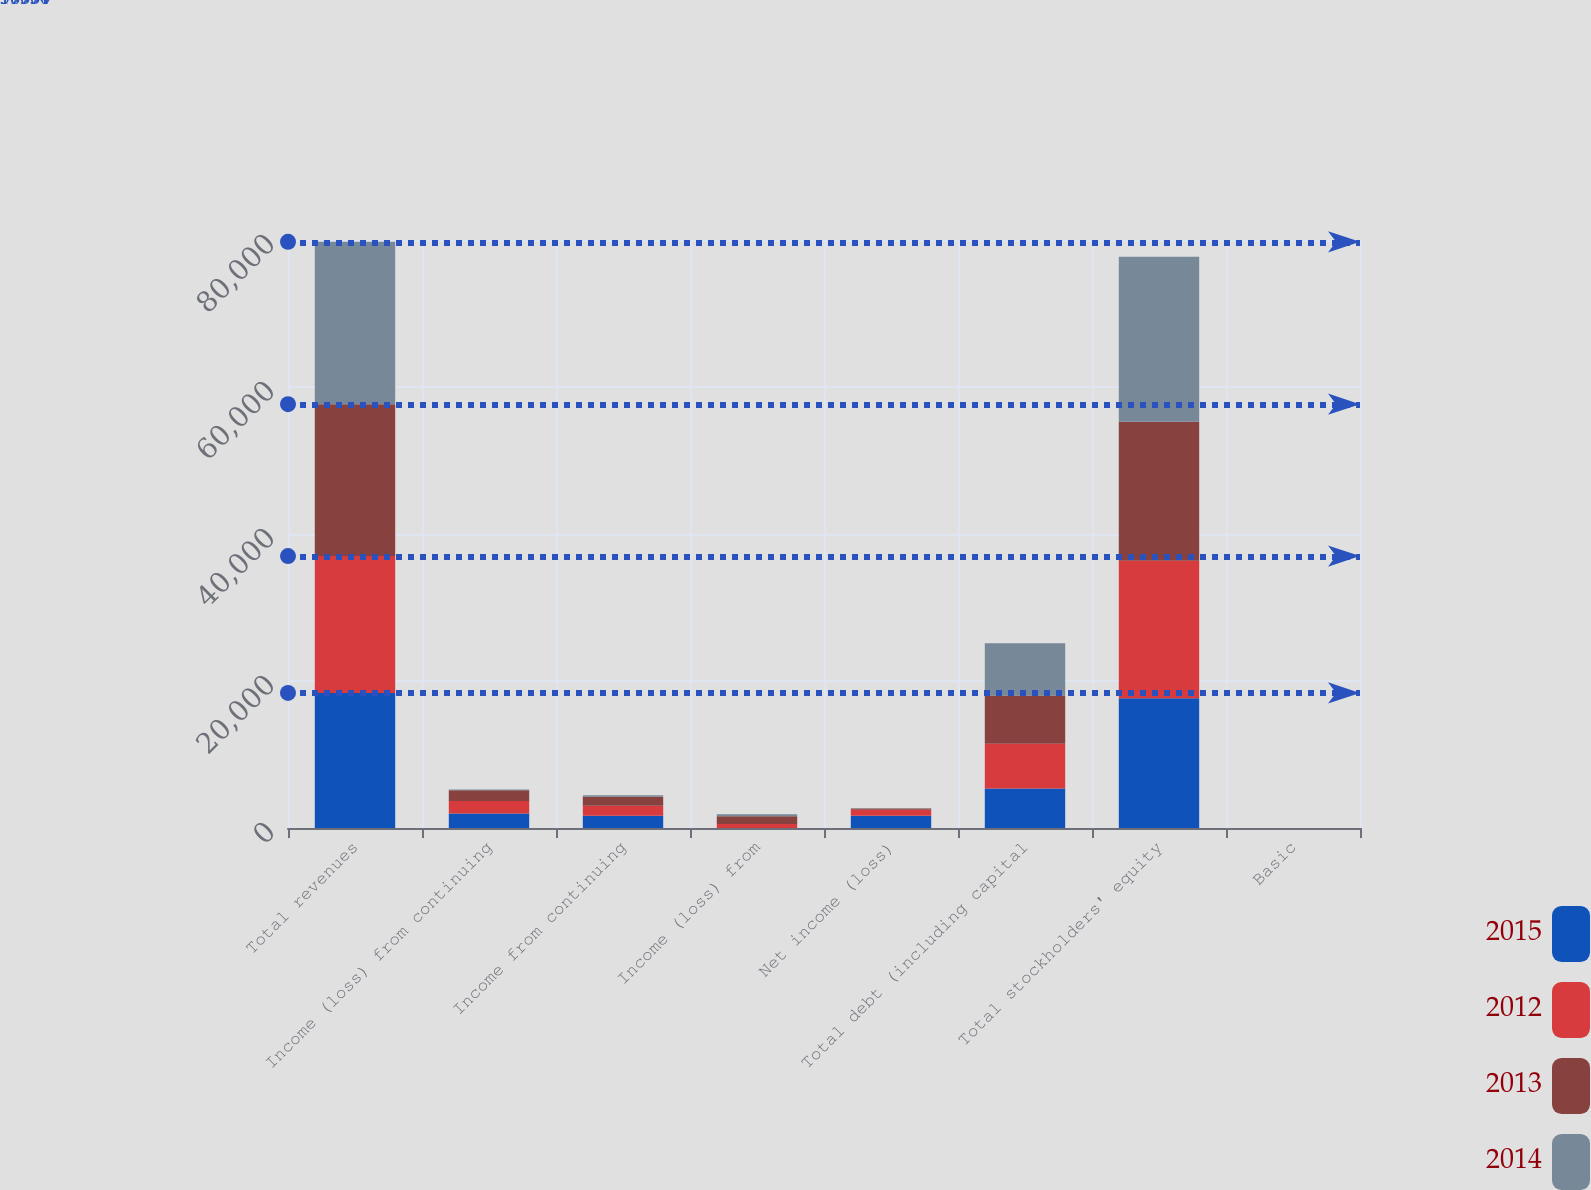<chart> <loc_0><loc_0><loc_500><loc_500><stacked_bar_chart><ecel><fcel>Total revenues<fcel>Income (loss) from continuing<fcel>Income from continuing<fcel>Income (loss) from<fcel>Net income (loss)<fcel>Total debt (including capital<fcel>Total stockholders' equity<fcel>Basic<nl><fcel>2015<fcel>18377<fcel>1978<fcel>1673<fcel>9<fcel>1682<fcel>5359<fcel>17642<fcel>4.05<nl><fcel>2012<fcel>18614<fcel>1699<fcel>1349<fcel>551<fcel>798<fcel>6109<fcel>18720<fcel>1.81<nl><fcel>2013<fcel>20673<fcel>1471<fcel>1225<fcel>1049<fcel>176<fcel>6544<fcel>18905<fcel>0.37<nl><fcel>2014<fcel>22086<fcel>89<fcel>220<fcel>258<fcel>38<fcel>7126<fcel>22447<fcel>0.18<nl></chart> 